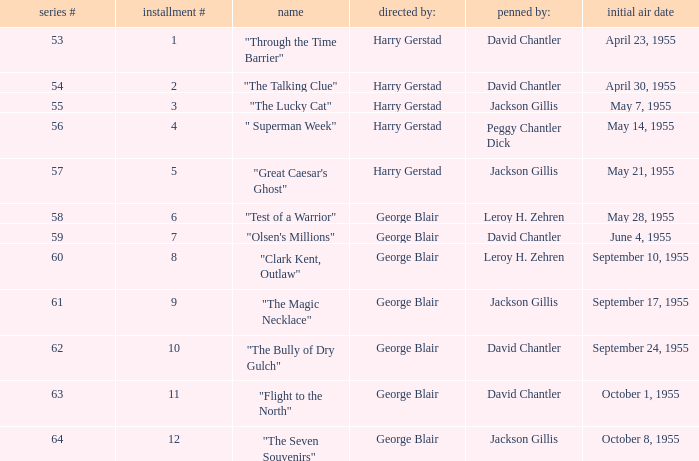Who directed the episode that was written by Jackson Gillis and Originally aired on May 21, 1955? Harry Gerstad. 